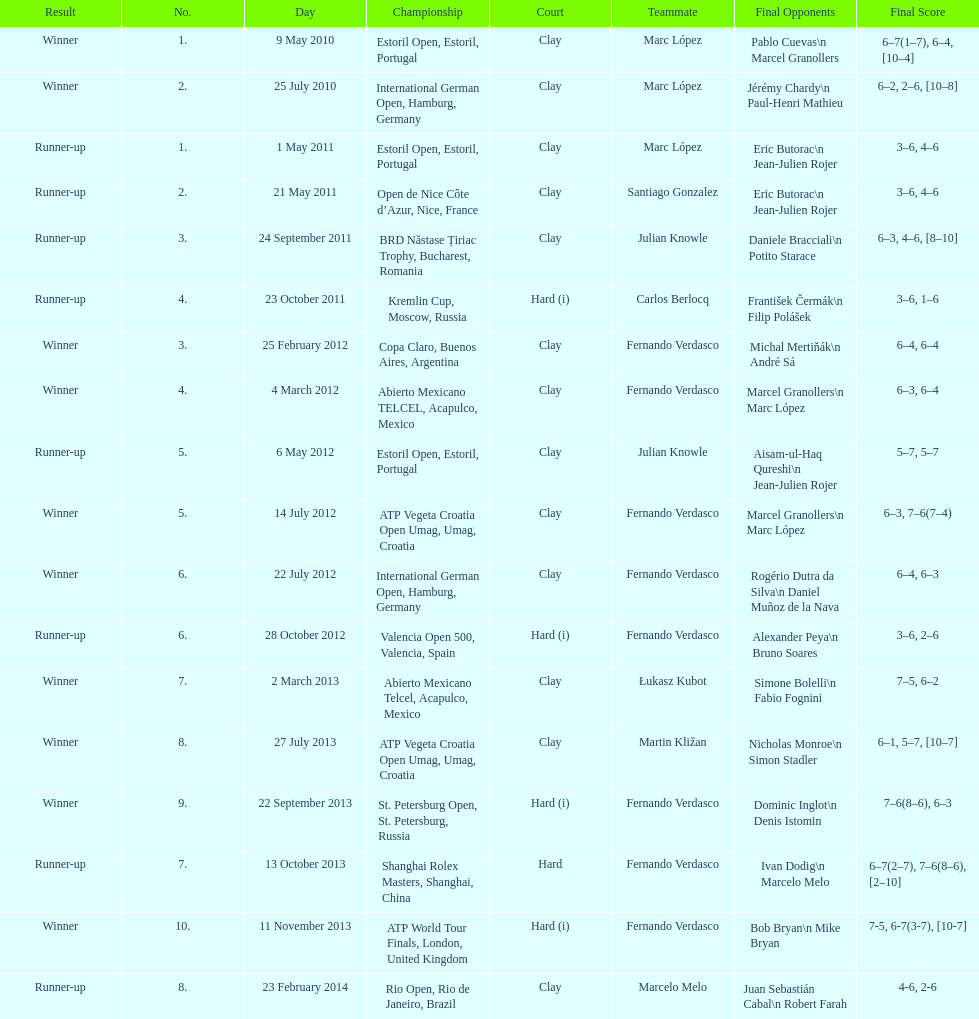How many partners from spain are listed? 2. 